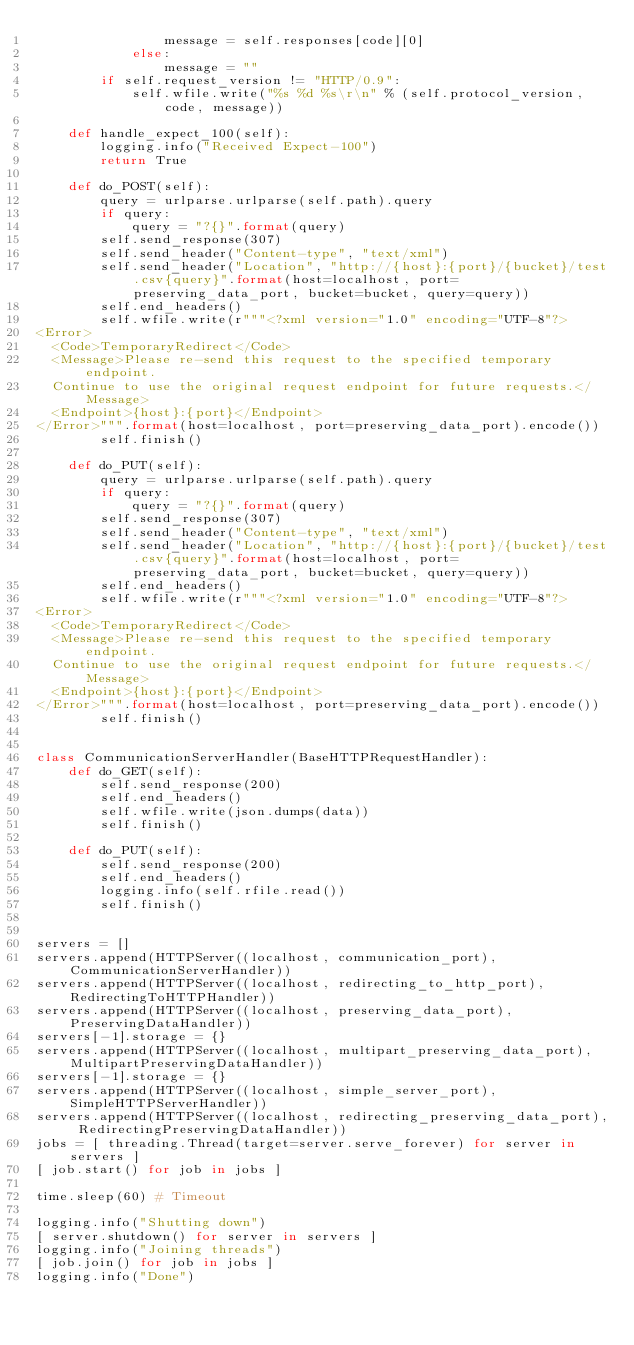<code> <loc_0><loc_0><loc_500><loc_500><_Python_>                message = self.responses[code][0]
            else:
                message = ""
        if self.request_version != "HTTP/0.9":
            self.wfile.write("%s %d %s\r\n" % (self.protocol_version, code, message))

    def handle_expect_100(self):
        logging.info("Received Expect-100")
        return True

    def do_POST(self):
        query = urlparse.urlparse(self.path).query
        if query:
            query = "?{}".format(query)
        self.send_response(307)
        self.send_header("Content-type", "text/xml")
        self.send_header("Location", "http://{host}:{port}/{bucket}/test.csv{query}".format(host=localhost, port=preserving_data_port, bucket=bucket, query=query))
        self.end_headers()
        self.wfile.write(r"""<?xml version="1.0" encoding="UTF-8"?>
<Error>
  <Code>TemporaryRedirect</Code>
  <Message>Please re-send this request to the specified temporary endpoint.
  Continue to use the original request endpoint for future requests.</Message>
  <Endpoint>{host}:{port}</Endpoint>
</Error>""".format(host=localhost, port=preserving_data_port).encode())
        self.finish()

    def do_PUT(self):
        query = urlparse.urlparse(self.path).query
        if query:
            query = "?{}".format(query)
        self.send_response(307)
        self.send_header("Content-type", "text/xml")
        self.send_header("Location", "http://{host}:{port}/{bucket}/test.csv{query}".format(host=localhost, port=preserving_data_port, bucket=bucket, query=query))
        self.end_headers()
        self.wfile.write(r"""<?xml version="1.0" encoding="UTF-8"?>
<Error>
  <Code>TemporaryRedirect</Code>
  <Message>Please re-send this request to the specified temporary endpoint.
  Continue to use the original request endpoint for future requests.</Message>
  <Endpoint>{host}:{port}</Endpoint>
</Error>""".format(host=localhost, port=preserving_data_port).encode())
        self.finish()


class CommunicationServerHandler(BaseHTTPRequestHandler):
    def do_GET(self):
        self.send_response(200)
        self.end_headers()
        self.wfile.write(json.dumps(data))
        self.finish()

    def do_PUT(self):
        self.send_response(200)
        self.end_headers()
        logging.info(self.rfile.read())
        self.finish()


servers = []
servers.append(HTTPServer((localhost, communication_port), CommunicationServerHandler))
servers.append(HTTPServer((localhost, redirecting_to_http_port), RedirectingToHTTPHandler))
servers.append(HTTPServer((localhost, preserving_data_port), PreservingDataHandler))
servers[-1].storage = {}
servers.append(HTTPServer((localhost, multipart_preserving_data_port), MultipartPreservingDataHandler))
servers[-1].storage = {}
servers.append(HTTPServer((localhost, simple_server_port), SimpleHTTPServerHandler))
servers.append(HTTPServer((localhost, redirecting_preserving_data_port), RedirectingPreservingDataHandler))
jobs = [ threading.Thread(target=server.serve_forever) for server in servers ]
[ job.start() for job in jobs ]

time.sleep(60) # Timeout

logging.info("Shutting down")
[ server.shutdown() for server in servers ]
logging.info("Joining threads")
[ job.join() for job in jobs ]
logging.info("Done")
</code> 